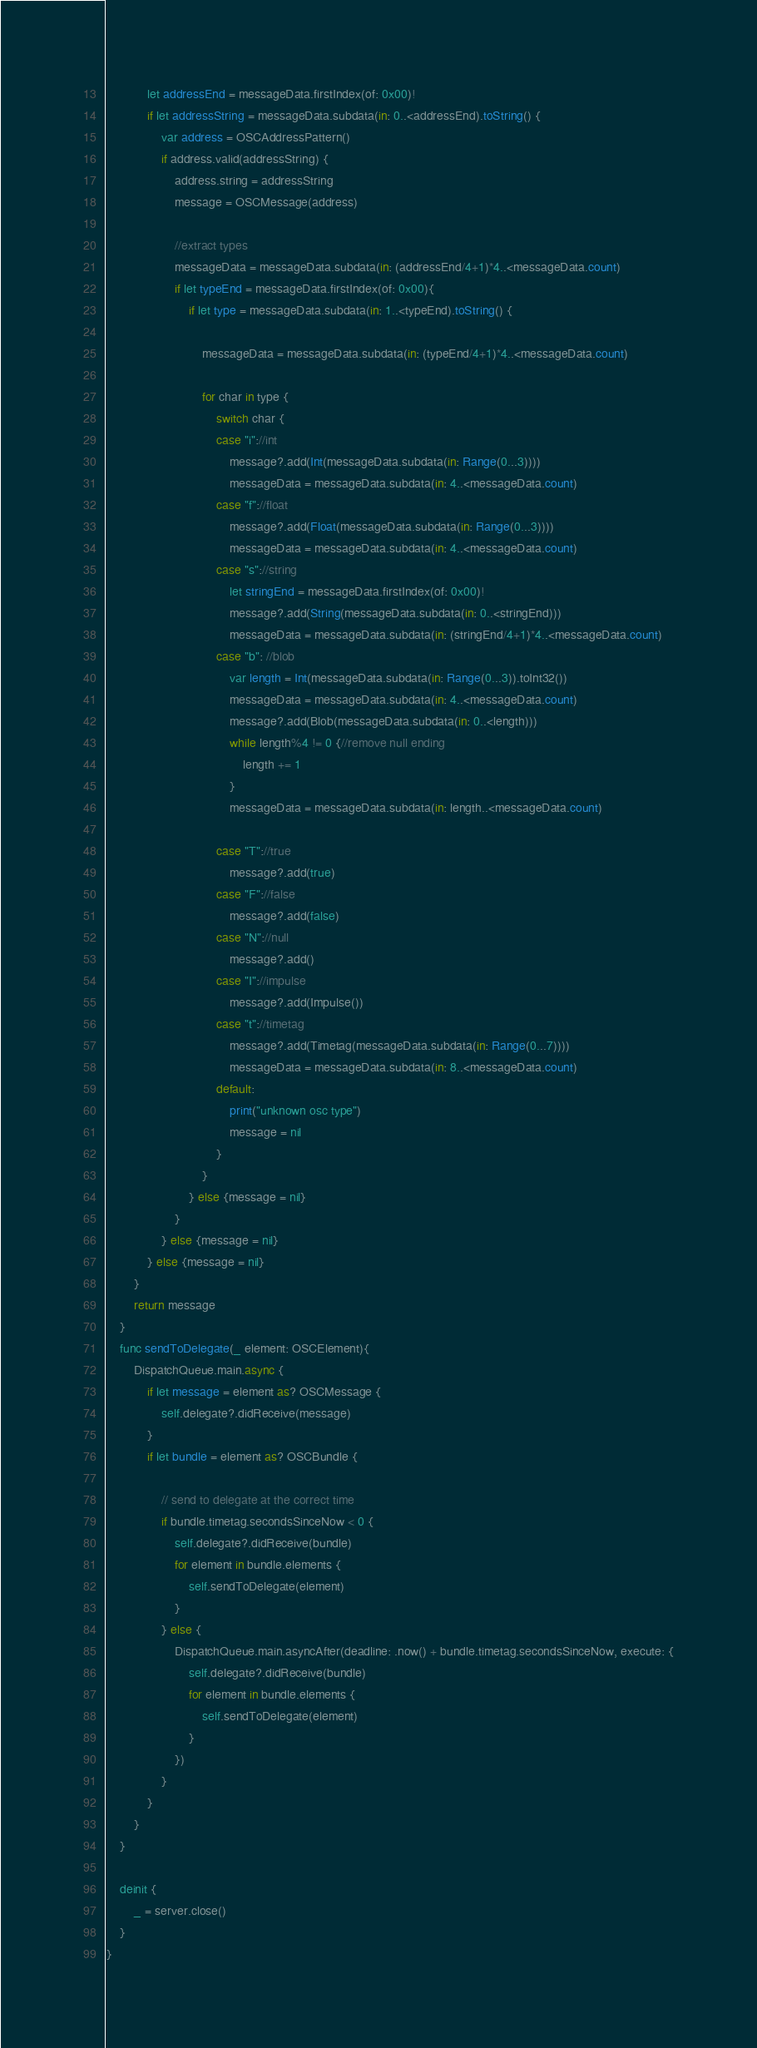<code> <loc_0><loc_0><loc_500><loc_500><_Swift_>            let addressEnd = messageData.firstIndex(of: 0x00)!
            if let addressString = messageData.subdata(in: 0..<addressEnd).toString() {
                var address = OSCAddressPattern()
                if address.valid(addressString) {
                    address.string = addressString
                    message = OSCMessage(address)

                    //extract types
                    messageData = messageData.subdata(in: (addressEnd/4+1)*4..<messageData.count)
                    if let typeEnd = messageData.firstIndex(of: 0x00){
                        if let type = messageData.subdata(in: 1..<typeEnd).toString() {

                            messageData = messageData.subdata(in: (typeEnd/4+1)*4..<messageData.count)

                            for char in type {
                                switch char {
                                case "i"://int
                                    message?.add(Int(messageData.subdata(in: Range(0...3))))
                                    messageData = messageData.subdata(in: 4..<messageData.count)
                                case "f"://float
                                    message?.add(Float(messageData.subdata(in: Range(0...3))))
                                    messageData = messageData.subdata(in: 4..<messageData.count)
                                case "s"://string
                                    let stringEnd = messageData.firstIndex(of: 0x00)!
                                    message?.add(String(messageData.subdata(in: 0..<stringEnd)))
                                    messageData = messageData.subdata(in: (stringEnd/4+1)*4..<messageData.count)
                                case "b": //blob
                                    var length = Int(messageData.subdata(in: Range(0...3)).toInt32())
                                    messageData = messageData.subdata(in: 4..<messageData.count)
                                    message?.add(Blob(messageData.subdata(in: 0..<length)))
                                    while length%4 != 0 {//remove null ending
                                        length += 1
                                    }
                                    messageData = messageData.subdata(in: length..<messageData.count)

                                case "T"://true
                                    message?.add(true)
                                case "F"://false
                                    message?.add(false)
                                case "N"://null
                                    message?.add()
                                case "I"://impulse
                                    message?.add(Impulse())
                                case "t"://timetag
                                    message?.add(Timetag(messageData.subdata(in: Range(0...7))))
                                    messageData = messageData.subdata(in: 8..<messageData.count)
                                default:
                                    print("unknown osc type")
                                    message = nil
                                }
                            }
                        } else {message = nil}
                    }
                } else {message = nil}
            } else {message = nil}
        }
        return message
    }
    func sendToDelegate(_ element: OSCElement){
        DispatchQueue.main.async {
            if let message = element as? OSCMessage {
                self.delegate?.didReceive(message)
            }
            if let bundle = element as? OSCBundle {
                
                // send to delegate at the correct time
                if bundle.timetag.secondsSinceNow < 0 {
                    self.delegate?.didReceive(bundle)
                    for element in bundle.elements {
                        self.sendToDelegate(element)
                    }
                } else {
                    DispatchQueue.main.asyncAfter(deadline: .now() + bundle.timetag.secondsSinceNow, execute: {
                        self.delegate?.didReceive(bundle)
                        for element in bundle.elements {
                            self.sendToDelegate(element)
                        }
                    })
                }
            }
        }
    }
    
    deinit {
        _ = server.close()
    }
}
</code> 